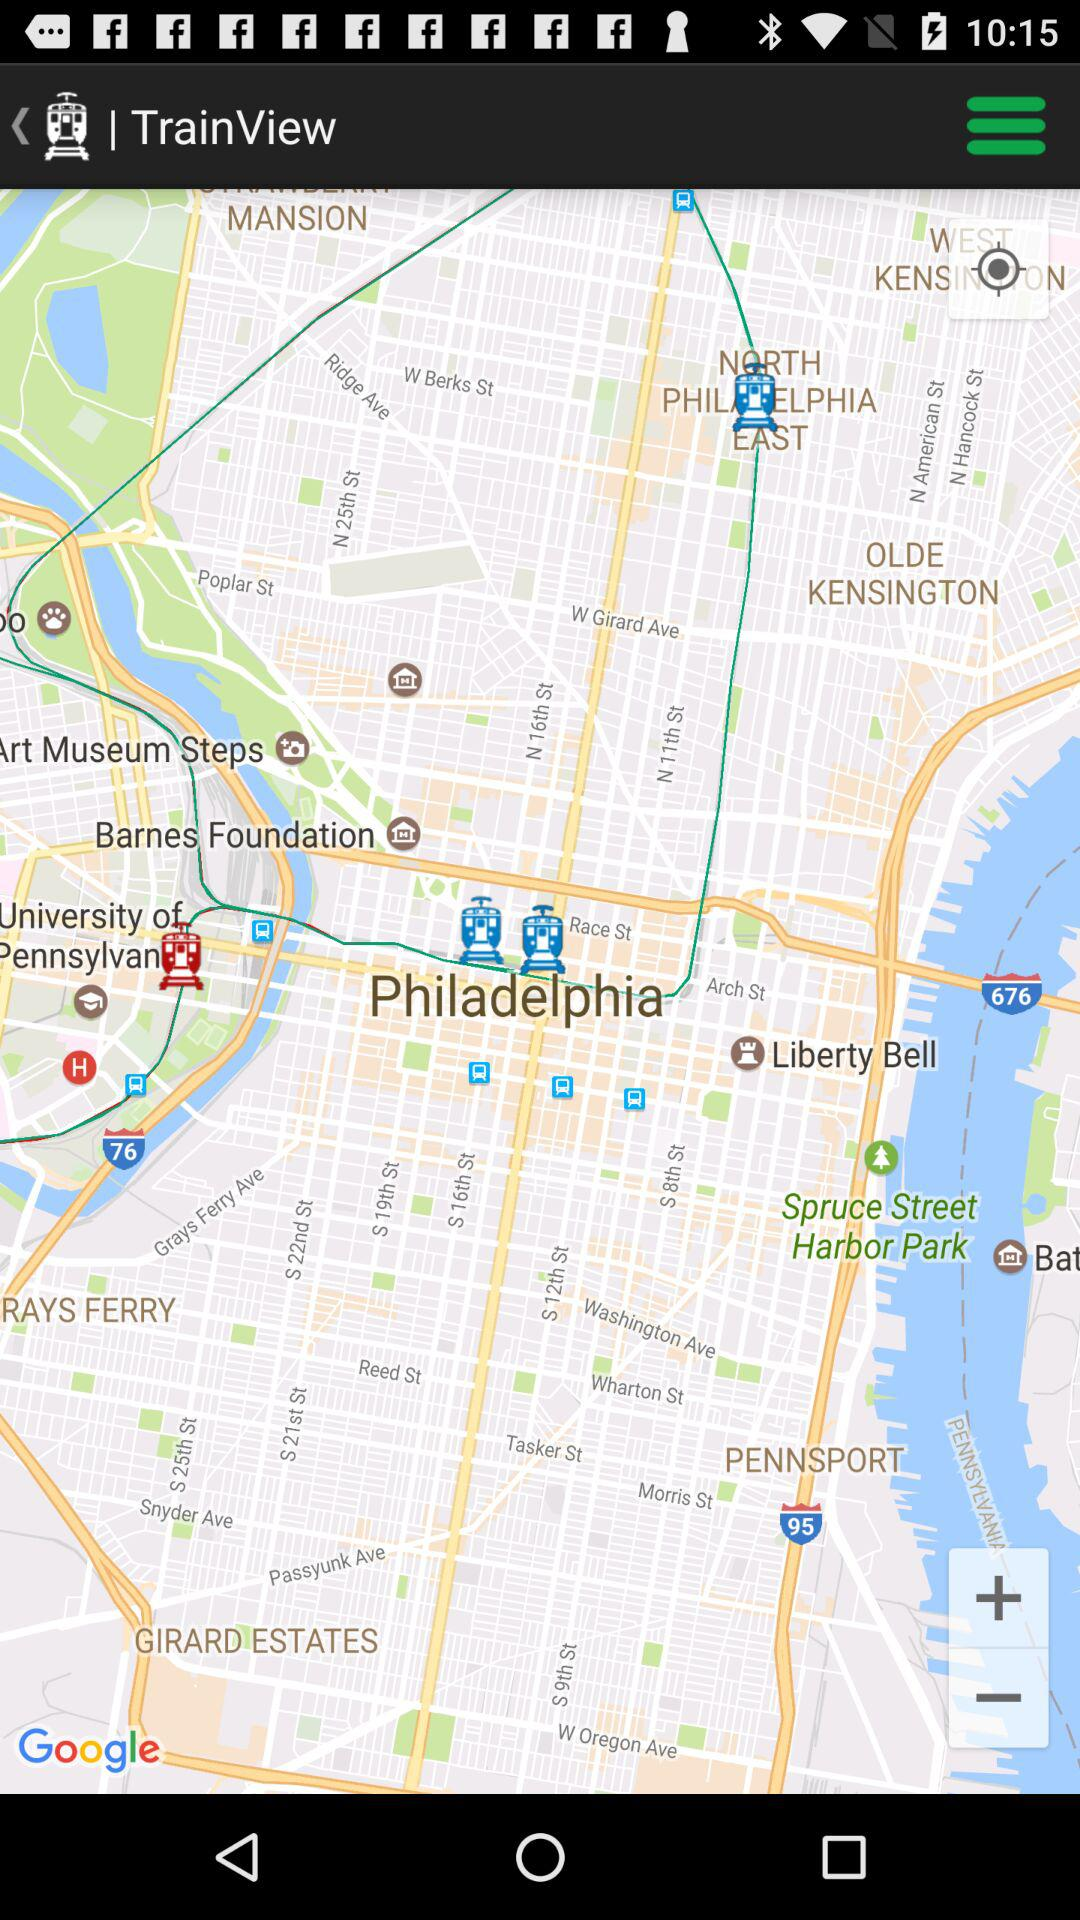What is the application name? The application name is "TrainView". 